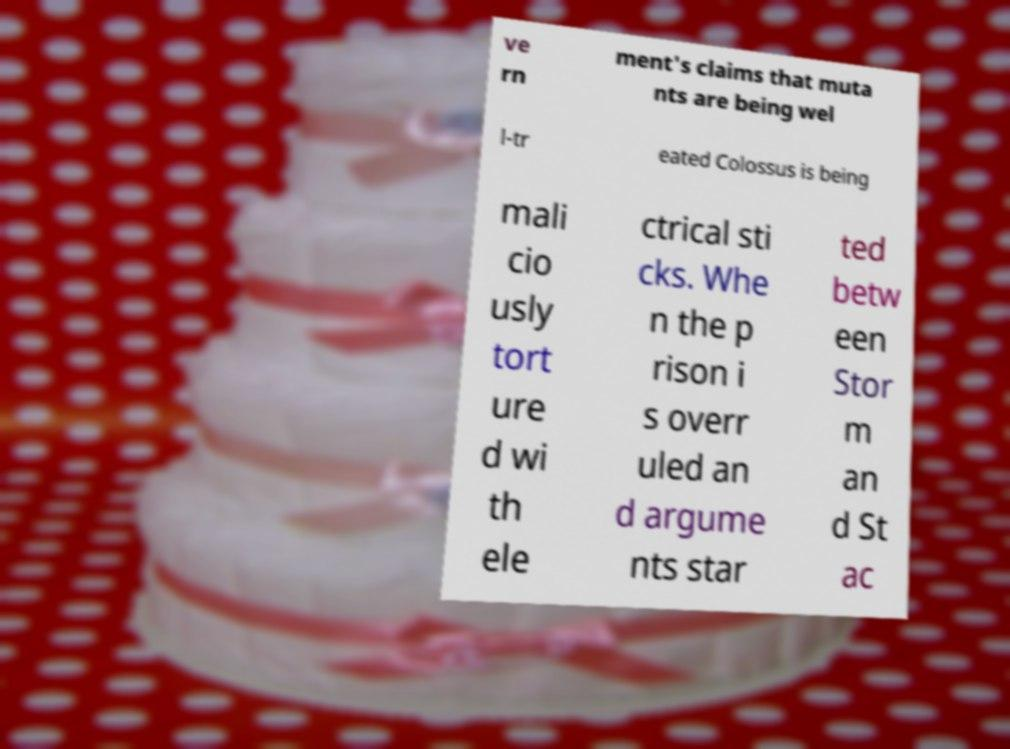For documentation purposes, I need the text within this image transcribed. Could you provide that? ve rn ment's claims that muta nts are being wel l-tr eated Colossus is being mali cio usly tort ure d wi th ele ctrical sti cks. Whe n the p rison i s overr uled an d argume nts star ted betw een Stor m an d St ac 